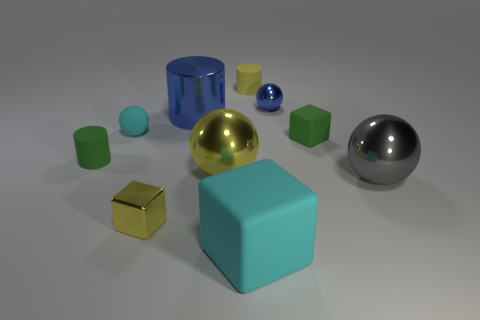What number of objects are small green matte things or tiny cubes that are behind the small yellow metal block?
Provide a short and direct response. 2. What color is the large block?
Provide a succinct answer. Cyan. What material is the tiny cube that is left of the cyan matte thing that is on the right side of the cyan object behind the yellow metal cube?
Make the answer very short. Metal. There is a blue cylinder that is made of the same material as the large gray ball; what size is it?
Your answer should be compact. Large. Are there any metallic things of the same color as the big matte cube?
Your answer should be very brief. No. There is a metal cube; is it the same size as the green rubber thing on the right side of the big cube?
Offer a very short reply. Yes. What number of big things are to the right of the tiny yellow object on the left side of the metal ball that is left of the tiny metal sphere?
Keep it short and to the point. 4. The thing that is the same color as the large rubber block is what size?
Provide a succinct answer. Small. Are there any small green matte cylinders behind the rubber ball?
Keep it short and to the point. No. What is the shape of the small yellow rubber object?
Give a very brief answer. Cylinder. 